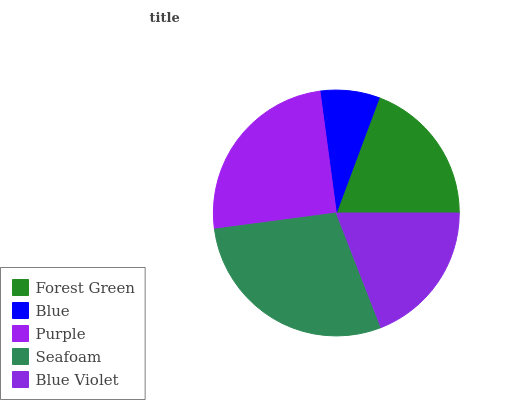Is Blue the minimum?
Answer yes or no. Yes. Is Seafoam the maximum?
Answer yes or no. Yes. Is Purple the minimum?
Answer yes or no. No. Is Purple the maximum?
Answer yes or no. No. Is Purple greater than Blue?
Answer yes or no. Yes. Is Blue less than Purple?
Answer yes or no. Yes. Is Blue greater than Purple?
Answer yes or no. No. Is Purple less than Blue?
Answer yes or no. No. Is Forest Green the high median?
Answer yes or no. Yes. Is Forest Green the low median?
Answer yes or no. Yes. Is Blue the high median?
Answer yes or no. No. Is Seafoam the low median?
Answer yes or no. No. 